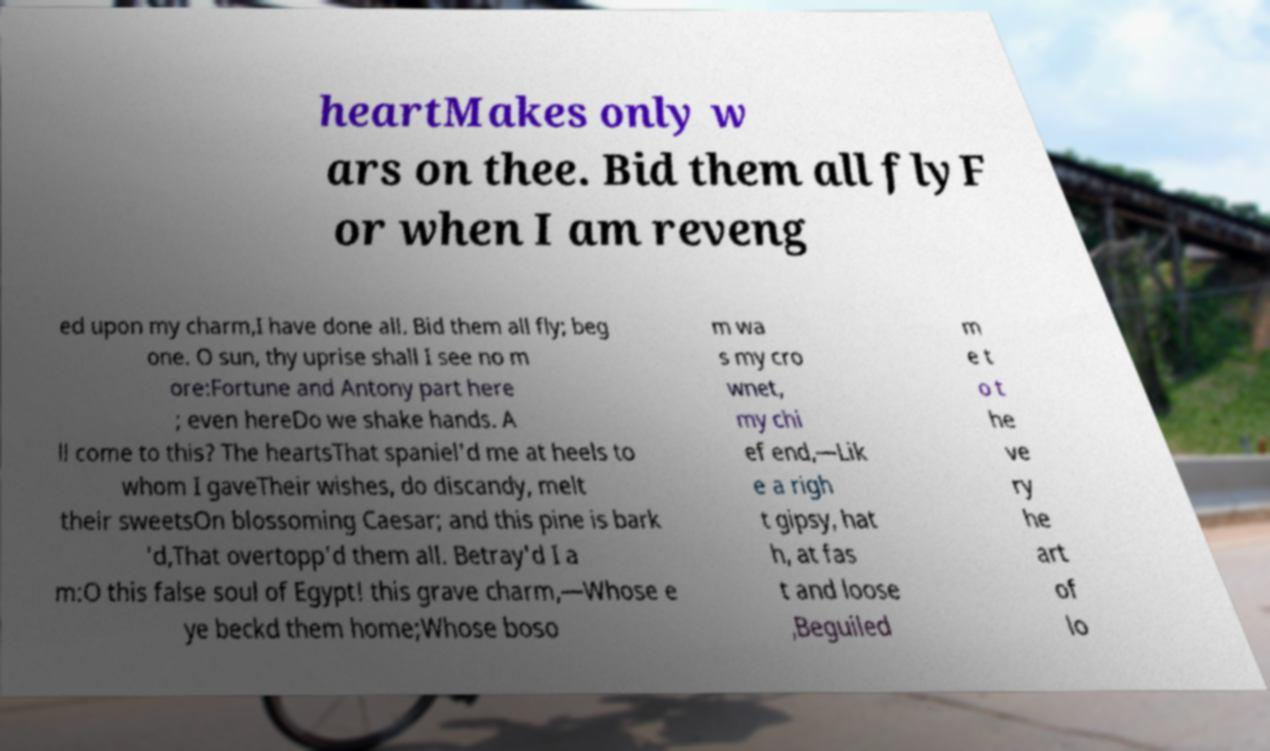Could you assist in decoding the text presented in this image and type it out clearly? heartMakes only w ars on thee. Bid them all flyF or when I am reveng ed upon my charm,I have done all. Bid them all fly; beg one. O sun, thy uprise shall I see no m ore:Fortune and Antony part here ; even hereDo we shake hands. A ll come to this? The heartsThat spaniel'd me at heels to whom I gaveTheir wishes, do discandy, melt their sweetsOn blossoming Caesar; and this pine is bark 'd,That overtopp'd them all. Betray'd I a m:O this false soul of Egypt! this grave charm,—Whose e ye beckd them home;Whose boso m wa s my cro wnet, my chi ef end,—Lik e a righ t gipsy, hat h, at fas t and loose ,Beguiled m e t o t he ve ry he art of lo 